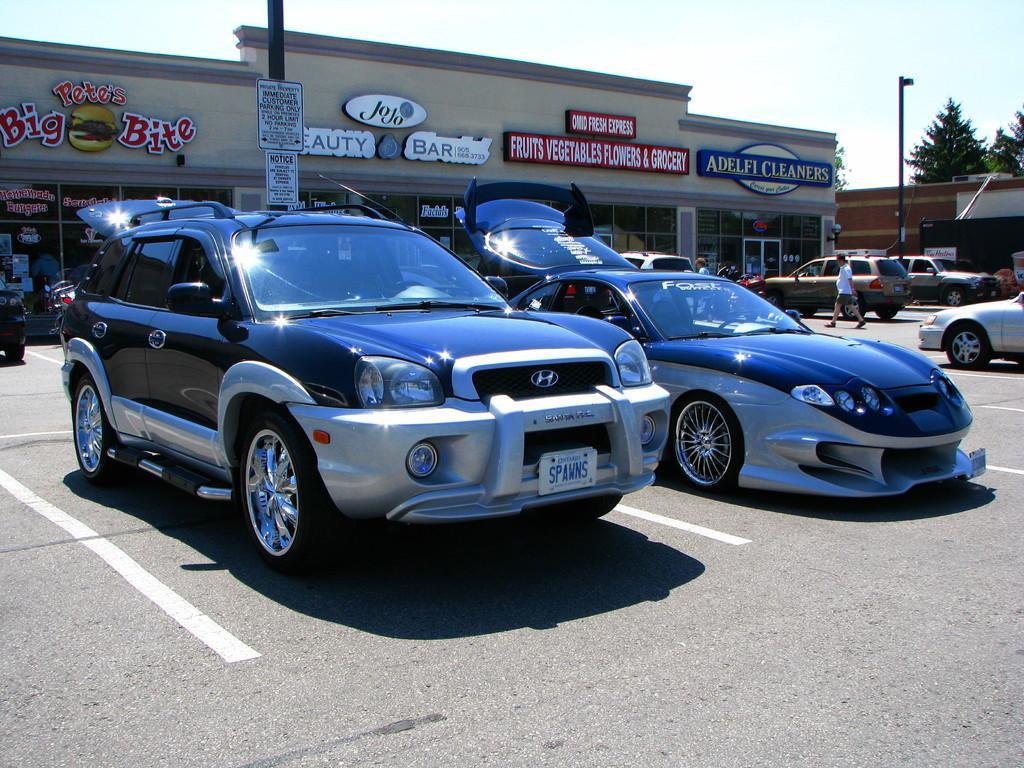How would you summarize this image in a sentence or two? In this image we can see some cars placed on the road. On the backside we can see a building with windows and name boards, a pole with some boards on it, trees, some people walking on the road and the sky which looks cloudy. 